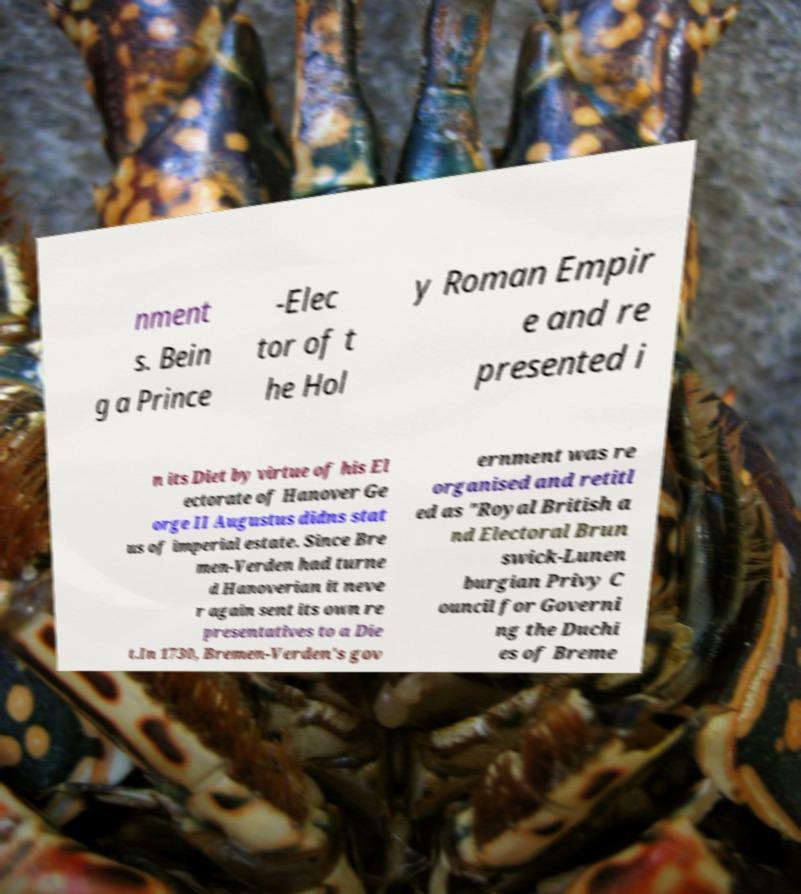Could you assist in decoding the text presented in this image and type it out clearly? nment s. Bein g a Prince -Elec tor of t he Hol y Roman Empir e and re presented i n its Diet by virtue of his El ectorate of Hanover Ge orge II Augustus didns stat us of imperial estate. Since Bre men-Verden had turne d Hanoverian it neve r again sent its own re presentatives to a Die t.In 1730, Bremen-Verden's gov ernment was re organised and retitl ed as "Royal British a nd Electoral Brun swick-Lunen burgian Privy C ouncil for Governi ng the Duchi es of Breme 